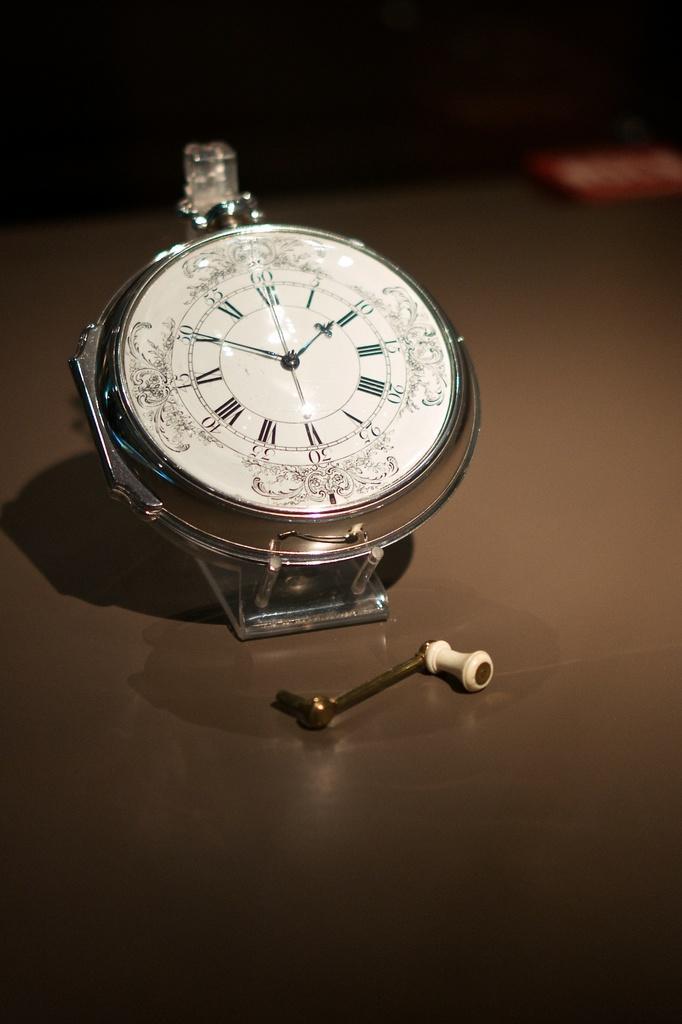Could you give a brief overview of what you see in this image? In this image we can see a watch dial and some other object on a surface. In the background it is blur. 